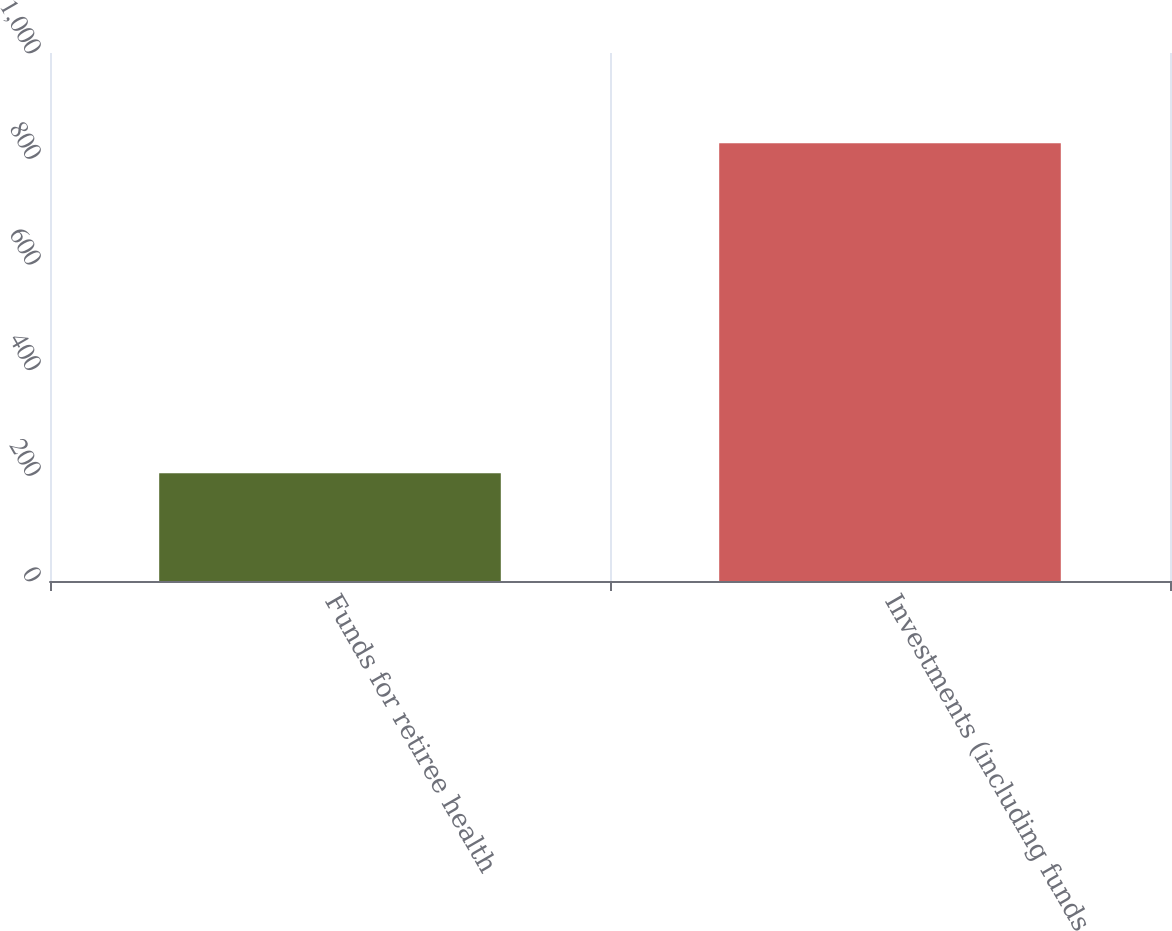Convert chart to OTSL. <chart><loc_0><loc_0><loc_500><loc_500><bar_chart><fcel>Funds for retiree health<fcel>Investments (including funds<nl><fcel>204<fcel>829<nl></chart> 